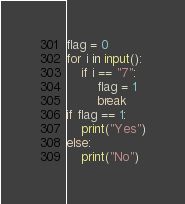Convert code to text. <code><loc_0><loc_0><loc_500><loc_500><_Python_>flag = 0
for i in input():
    if i == "7":
        flag = 1
        break
if flag == 1:
    print("Yes")
else:
    print("No")
</code> 